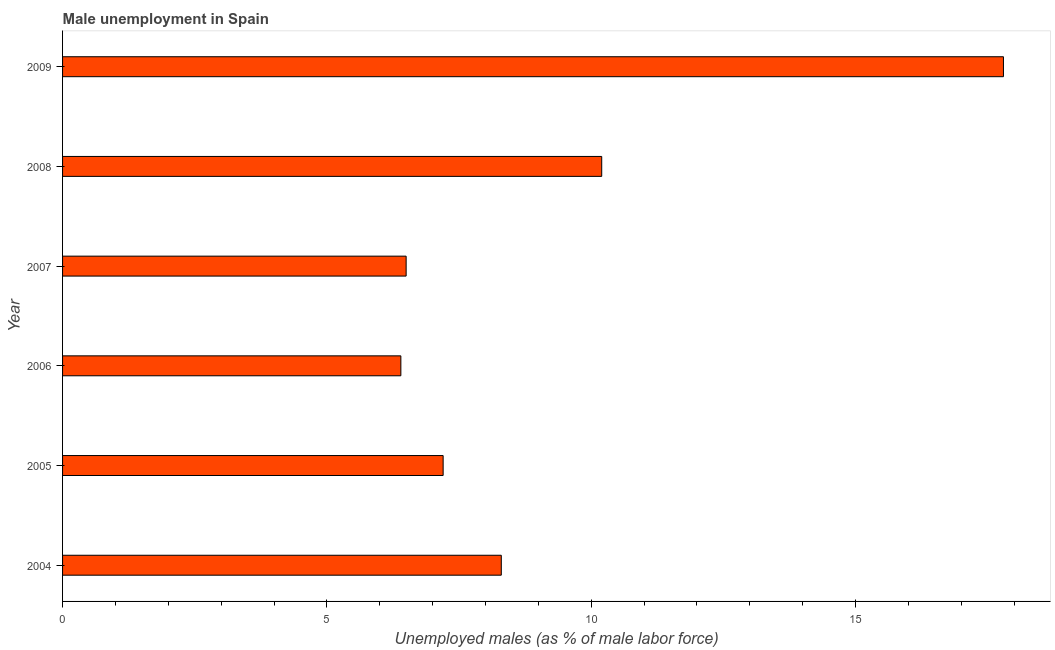Does the graph contain grids?
Offer a terse response. No. What is the title of the graph?
Provide a succinct answer. Male unemployment in Spain. What is the label or title of the X-axis?
Ensure brevity in your answer.  Unemployed males (as % of male labor force). What is the unemployed males population in 2008?
Your answer should be very brief. 10.2. Across all years, what is the maximum unemployed males population?
Your answer should be compact. 17.8. Across all years, what is the minimum unemployed males population?
Offer a very short reply. 6.4. In which year was the unemployed males population maximum?
Ensure brevity in your answer.  2009. In which year was the unemployed males population minimum?
Provide a succinct answer. 2006. What is the sum of the unemployed males population?
Offer a terse response. 56.4. What is the median unemployed males population?
Ensure brevity in your answer.  7.75. What is the ratio of the unemployed males population in 2004 to that in 2007?
Provide a succinct answer. 1.28. Is the unemployed males population in 2004 less than that in 2007?
Offer a very short reply. No. Is the difference between the unemployed males population in 2004 and 2005 greater than the difference between any two years?
Your answer should be very brief. No. What is the difference between the highest and the second highest unemployed males population?
Your answer should be compact. 7.6. In how many years, is the unemployed males population greater than the average unemployed males population taken over all years?
Your answer should be very brief. 2. How many bars are there?
Your answer should be compact. 6. Are all the bars in the graph horizontal?
Make the answer very short. Yes. How many years are there in the graph?
Provide a succinct answer. 6. What is the difference between two consecutive major ticks on the X-axis?
Provide a succinct answer. 5. Are the values on the major ticks of X-axis written in scientific E-notation?
Offer a terse response. No. What is the Unemployed males (as % of male labor force) of 2004?
Provide a succinct answer. 8.3. What is the Unemployed males (as % of male labor force) of 2005?
Your answer should be very brief. 7.2. What is the Unemployed males (as % of male labor force) in 2006?
Your answer should be compact. 6.4. What is the Unemployed males (as % of male labor force) in 2008?
Your answer should be very brief. 10.2. What is the Unemployed males (as % of male labor force) in 2009?
Give a very brief answer. 17.8. What is the difference between the Unemployed males (as % of male labor force) in 2004 and 2005?
Offer a very short reply. 1.1. What is the difference between the Unemployed males (as % of male labor force) in 2004 and 2007?
Keep it short and to the point. 1.8. What is the difference between the Unemployed males (as % of male labor force) in 2004 and 2008?
Your answer should be very brief. -1.9. What is the difference between the Unemployed males (as % of male labor force) in 2004 and 2009?
Provide a short and direct response. -9.5. What is the difference between the Unemployed males (as % of male labor force) in 2005 and 2006?
Offer a terse response. 0.8. What is the difference between the Unemployed males (as % of male labor force) in 2005 and 2008?
Your answer should be compact. -3. What is the difference between the Unemployed males (as % of male labor force) in 2006 and 2007?
Your response must be concise. -0.1. What is the difference between the Unemployed males (as % of male labor force) in 2007 and 2008?
Make the answer very short. -3.7. What is the ratio of the Unemployed males (as % of male labor force) in 2004 to that in 2005?
Provide a short and direct response. 1.15. What is the ratio of the Unemployed males (as % of male labor force) in 2004 to that in 2006?
Offer a terse response. 1.3. What is the ratio of the Unemployed males (as % of male labor force) in 2004 to that in 2007?
Make the answer very short. 1.28. What is the ratio of the Unemployed males (as % of male labor force) in 2004 to that in 2008?
Offer a terse response. 0.81. What is the ratio of the Unemployed males (as % of male labor force) in 2004 to that in 2009?
Offer a terse response. 0.47. What is the ratio of the Unemployed males (as % of male labor force) in 2005 to that in 2006?
Provide a succinct answer. 1.12. What is the ratio of the Unemployed males (as % of male labor force) in 2005 to that in 2007?
Your answer should be very brief. 1.11. What is the ratio of the Unemployed males (as % of male labor force) in 2005 to that in 2008?
Keep it short and to the point. 0.71. What is the ratio of the Unemployed males (as % of male labor force) in 2005 to that in 2009?
Provide a succinct answer. 0.4. What is the ratio of the Unemployed males (as % of male labor force) in 2006 to that in 2008?
Provide a succinct answer. 0.63. What is the ratio of the Unemployed males (as % of male labor force) in 2006 to that in 2009?
Your response must be concise. 0.36. What is the ratio of the Unemployed males (as % of male labor force) in 2007 to that in 2008?
Your answer should be compact. 0.64. What is the ratio of the Unemployed males (as % of male labor force) in 2007 to that in 2009?
Provide a short and direct response. 0.36. What is the ratio of the Unemployed males (as % of male labor force) in 2008 to that in 2009?
Make the answer very short. 0.57. 